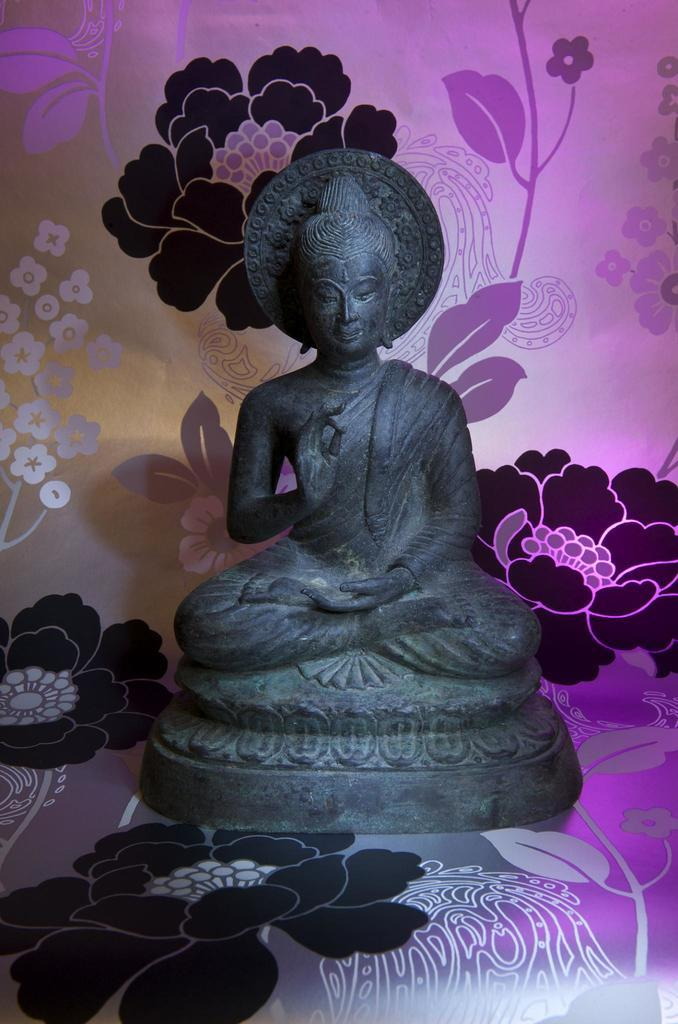What type of furniture is in the middle of the image? There is a sofa in the middle of the image. What is the position of the statue in the image? The statue is on the sofa. How many pizzas are being delivered to the letter in the image? There are no pizzas or letters present in the image; it only features a sofa and a statue. 